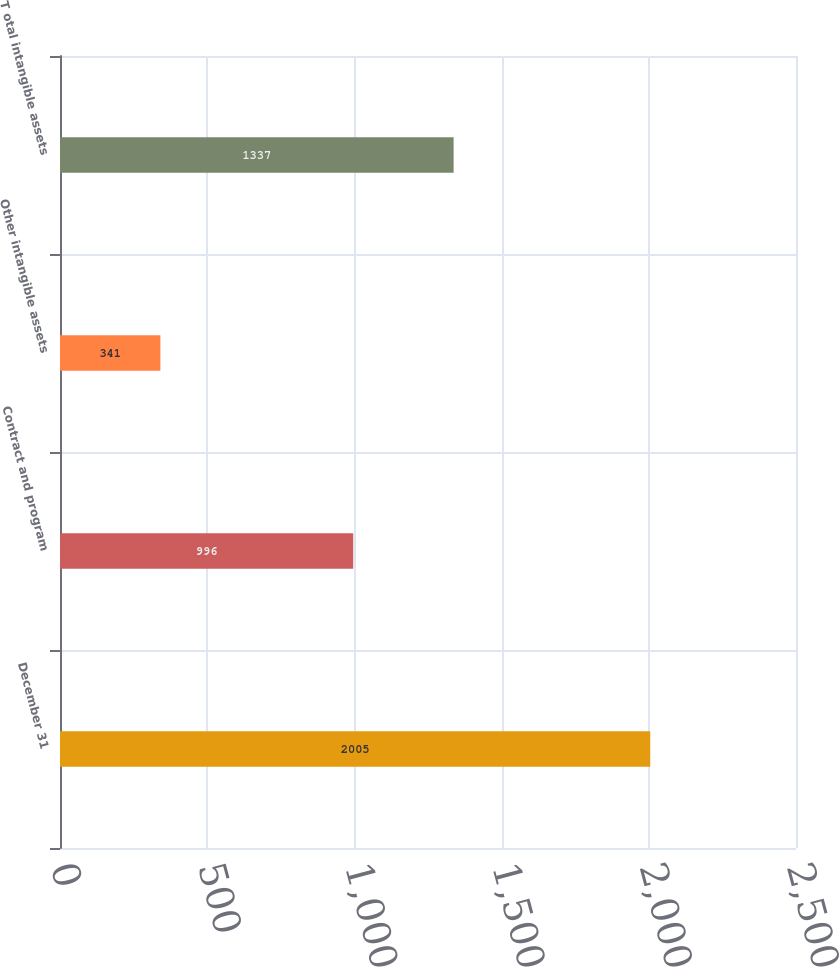<chart> <loc_0><loc_0><loc_500><loc_500><bar_chart><fcel>December 31<fcel>Contract and program<fcel>Other intangible assets<fcel>T otal intangible assets<nl><fcel>2005<fcel>996<fcel>341<fcel>1337<nl></chart> 